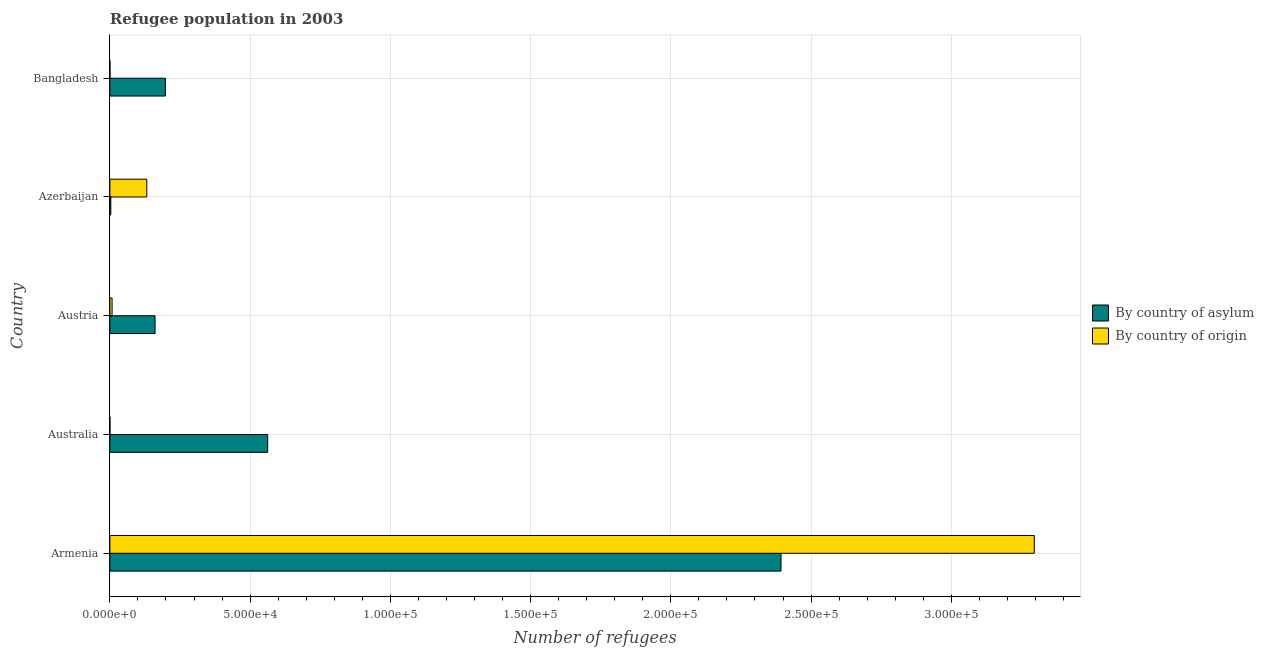How many different coloured bars are there?
Provide a succinct answer. 2. How many bars are there on the 3rd tick from the bottom?
Provide a succinct answer. 2. What is the label of the 2nd group of bars from the top?
Keep it short and to the point. Azerbaijan. What is the number of refugees by country of asylum in Australia?
Offer a very short reply. 5.63e+04. Across all countries, what is the maximum number of refugees by country of asylum?
Your answer should be compact. 2.39e+05. Across all countries, what is the minimum number of refugees by country of origin?
Provide a succinct answer. 5. In which country was the number of refugees by country of asylum maximum?
Make the answer very short. Armenia. In which country was the number of refugees by country of asylum minimum?
Keep it short and to the point. Azerbaijan. What is the total number of refugees by country of asylum in the graph?
Keep it short and to the point. 3.32e+05. What is the difference between the number of refugees by country of origin in Azerbaijan and that in Bangladesh?
Your answer should be compact. 1.31e+04. What is the difference between the number of refugees by country of origin in Australia and the number of refugees by country of asylum in Armenia?
Keep it short and to the point. -2.39e+05. What is the average number of refugees by country of origin per country?
Give a very brief answer. 6.87e+04. What is the difference between the number of refugees by country of origin and number of refugees by country of asylum in Azerbaijan?
Make the answer very short. 1.28e+04. What is the ratio of the number of refugees by country of asylum in Austria to that in Azerbaijan?
Your answer should be compact. 49.41. Is the difference between the number of refugees by country of origin in Armenia and Bangladesh greater than the difference between the number of refugees by country of asylum in Armenia and Bangladesh?
Offer a very short reply. Yes. What is the difference between the highest and the second highest number of refugees by country of asylum?
Give a very brief answer. 1.83e+05. What is the difference between the highest and the lowest number of refugees by country of origin?
Keep it short and to the point. 3.30e+05. In how many countries, is the number of refugees by country of origin greater than the average number of refugees by country of origin taken over all countries?
Keep it short and to the point. 1. Is the sum of the number of refugees by country of origin in Australia and Azerbaijan greater than the maximum number of refugees by country of asylum across all countries?
Make the answer very short. No. What does the 2nd bar from the top in Bangladesh represents?
Offer a terse response. By country of asylum. What does the 1st bar from the bottom in Armenia represents?
Ensure brevity in your answer.  By country of asylum. Where does the legend appear in the graph?
Keep it short and to the point. Center right. What is the title of the graph?
Offer a terse response. Refugee population in 2003. What is the label or title of the X-axis?
Give a very brief answer. Number of refugees. What is the Number of refugees in By country of asylum in Armenia?
Provide a succinct answer. 2.39e+05. What is the Number of refugees of By country of origin in Armenia?
Your response must be concise. 3.30e+05. What is the Number of refugees in By country of asylum in Australia?
Ensure brevity in your answer.  5.63e+04. What is the Number of refugees of By country of origin in Australia?
Make the answer very short. 5. What is the Number of refugees in By country of asylum in Austria?
Ensure brevity in your answer.  1.61e+04. What is the Number of refugees in By country of origin in Austria?
Ensure brevity in your answer.  784. What is the Number of refugees in By country of asylum in Azerbaijan?
Provide a succinct answer. 326. What is the Number of refugees of By country of origin in Azerbaijan?
Your response must be concise. 1.32e+04. What is the Number of refugees of By country of asylum in Bangladesh?
Give a very brief answer. 1.98e+04. What is the Number of refugees of By country of origin in Bangladesh?
Give a very brief answer. 15. Across all countries, what is the maximum Number of refugees in By country of asylum?
Keep it short and to the point. 2.39e+05. Across all countries, what is the maximum Number of refugees of By country of origin?
Ensure brevity in your answer.  3.30e+05. Across all countries, what is the minimum Number of refugees of By country of asylum?
Your answer should be compact. 326. Across all countries, what is the minimum Number of refugees of By country of origin?
Your answer should be compact. 5. What is the total Number of refugees of By country of asylum in the graph?
Offer a very short reply. 3.32e+05. What is the total Number of refugees in By country of origin in the graph?
Provide a short and direct response. 3.44e+05. What is the difference between the Number of refugees in By country of asylum in Armenia and that in Australia?
Provide a succinct answer. 1.83e+05. What is the difference between the Number of refugees of By country of origin in Armenia and that in Australia?
Ensure brevity in your answer.  3.30e+05. What is the difference between the Number of refugees of By country of asylum in Armenia and that in Austria?
Ensure brevity in your answer.  2.23e+05. What is the difference between the Number of refugees of By country of origin in Armenia and that in Austria?
Give a very brief answer. 3.29e+05. What is the difference between the Number of refugees of By country of asylum in Armenia and that in Azerbaijan?
Ensure brevity in your answer.  2.39e+05. What is the difference between the Number of refugees of By country of origin in Armenia and that in Azerbaijan?
Give a very brief answer. 3.16e+05. What is the difference between the Number of refugees in By country of asylum in Armenia and that in Bangladesh?
Keep it short and to the point. 2.19e+05. What is the difference between the Number of refugees of By country of origin in Armenia and that in Bangladesh?
Offer a terse response. 3.30e+05. What is the difference between the Number of refugees in By country of asylum in Australia and that in Austria?
Ensure brevity in your answer.  4.01e+04. What is the difference between the Number of refugees in By country of origin in Australia and that in Austria?
Offer a very short reply. -779. What is the difference between the Number of refugees in By country of asylum in Australia and that in Azerbaijan?
Your response must be concise. 5.59e+04. What is the difference between the Number of refugees in By country of origin in Australia and that in Azerbaijan?
Keep it short and to the point. -1.32e+04. What is the difference between the Number of refugees in By country of asylum in Australia and that in Bangladesh?
Keep it short and to the point. 3.65e+04. What is the difference between the Number of refugees in By country of origin in Australia and that in Bangladesh?
Give a very brief answer. -10. What is the difference between the Number of refugees of By country of asylum in Austria and that in Azerbaijan?
Provide a succinct answer. 1.58e+04. What is the difference between the Number of refugees in By country of origin in Austria and that in Azerbaijan?
Ensure brevity in your answer.  -1.24e+04. What is the difference between the Number of refugees of By country of asylum in Austria and that in Bangladesh?
Your answer should be very brief. -3683. What is the difference between the Number of refugees in By country of origin in Austria and that in Bangladesh?
Your response must be concise. 769. What is the difference between the Number of refugees of By country of asylum in Azerbaijan and that in Bangladesh?
Keep it short and to the point. -1.95e+04. What is the difference between the Number of refugees of By country of origin in Azerbaijan and that in Bangladesh?
Provide a succinct answer. 1.31e+04. What is the difference between the Number of refugees of By country of asylum in Armenia and the Number of refugees of By country of origin in Australia?
Keep it short and to the point. 2.39e+05. What is the difference between the Number of refugees of By country of asylum in Armenia and the Number of refugees of By country of origin in Austria?
Your answer should be compact. 2.39e+05. What is the difference between the Number of refugees of By country of asylum in Armenia and the Number of refugees of By country of origin in Azerbaijan?
Your response must be concise. 2.26e+05. What is the difference between the Number of refugees in By country of asylum in Armenia and the Number of refugees in By country of origin in Bangladesh?
Provide a short and direct response. 2.39e+05. What is the difference between the Number of refugees in By country of asylum in Australia and the Number of refugees in By country of origin in Austria?
Your answer should be very brief. 5.55e+04. What is the difference between the Number of refugees in By country of asylum in Australia and the Number of refugees in By country of origin in Azerbaijan?
Make the answer very short. 4.31e+04. What is the difference between the Number of refugees of By country of asylum in Australia and the Number of refugees of By country of origin in Bangladesh?
Give a very brief answer. 5.62e+04. What is the difference between the Number of refugees in By country of asylum in Austria and the Number of refugees in By country of origin in Azerbaijan?
Keep it short and to the point. 2947. What is the difference between the Number of refugees in By country of asylum in Austria and the Number of refugees in By country of origin in Bangladesh?
Make the answer very short. 1.61e+04. What is the difference between the Number of refugees of By country of asylum in Azerbaijan and the Number of refugees of By country of origin in Bangladesh?
Offer a terse response. 311. What is the average Number of refugees of By country of asylum per country?
Your answer should be very brief. 6.64e+04. What is the average Number of refugees in By country of origin per country?
Make the answer very short. 6.87e+04. What is the difference between the Number of refugees in By country of asylum and Number of refugees in By country of origin in Armenia?
Provide a succinct answer. -9.03e+04. What is the difference between the Number of refugees of By country of asylum and Number of refugees of By country of origin in Australia?
Provide a succinct answer. 5.63e+04. What is the difference between the Number of refugees in By country of asylum and Number of refugees in By country of origin in Austria?
Provide a succinct answer. 1.53e+04. What is the difference between the Number of refugees in By country of asylum and Number of refugees in By country of origin in Azerbaijan?
Offer a terse response. -1.28e+04. What is the difference between the Number of refugees of By country of asylum and Number of refugees of By country of origin in Bangladesh?
Offer a terse response. 1.98e+04. What is the ratio of the Number of refugees in By country of asylum in Armenia to that in Australia?
Your answer should be very brief. 4.25. What is the ratio of the Number of refugees of By country of origin in Armenia to that in Australia?
Your answer should be compact. 6.59e+04. What is the ratio of the Number of refugees in By country of asylum in Armenia to that in Austria?
Provide a succinct answer. 14.85. What is the ratio of the Number of refugees of By country of origin in Armenia to that in Austria?
Ensure brevity in your answer.  420.39. What is the ratio of the Number of refugees of By country of asylum in Armenia to that in Azerbaijan?
Your answer should be very brief. 734.02. What is the ratio of the Number of refugees of By country of origin in Armenia to that in Azerbaijan?
Make the answer very short. 25.04. What is the ratio of the Number of refugees of By country of asylum in Armenia to that in Bangladesh?
Your response must be concise. 12.09. What is the ratio of the Number of refugees in By country of origin in Armenia to that in Bangladesh?
Your response must be concise. 2.20e+04. What is the ratio of the Number of refugees of By country of asylum in Australia to that in Austria?
Your answer should be very brief. 3.49. What is the ratio of the Number of refugees in By country of origin in Australia to that in Austria?
Give a very brief answer. 0.01. What is the ratio of the Number of refugees of By country of asylum in Australia to that in Azerbaijan?
Make the answer very short. 172.57. What is the ratio of the Number of refugees in By country of asylum in Australia to that in Bangladesh?
Offer a terse response. 2.84. What is the ratio of the Number of refugees in By country of asylum in Austria to that in Azerbaijan?
Offer a terse response. 49.41. What is the ratio of the Number of refugees of By country of origin in Austria to that in Azerbaijan?
Offer a terse response. 0.06. What is the ratio of the Number of refugees of By country of asylum in Austria to that in Bangladesh?
Your answer should be very brief. 0.81. What is the ratio of the Number of refugees of By country of origin in Austria to that in Bangladesh?
Keep it short and to the point. 52.27. What is the ratio of the Number of refugees of By country of asylum in Azerbaijan to that in Bangladesh?
Your response must be concise. 0.02. What is the ratio of the Number of refugees of By country of origin in Azerbaijan to that in Bangladesh?
Offer a terse response. 877.47. What is the difference between the highest and the second highest Number of refugees of By country of asylum?
Offer a terse response. 1.83e+05. What is the difference between the highest and the second highest Number of refugees of By country of origin?
Provide a succinct answer. 3.16e+05. What is the difference between the highest and the lowest Number of refugees of By country of asylum?
Your answer should be compact. 2.39e+05. What is the difference between the highest and the lowest Number of refugees of By country of origin?
Your answer should be compact. 3.30e+05. 